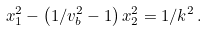Convert formula to latex. <formula><loc_0><loc_0><loc_500><loc_500>x _ { 1 } ^ { 2 } - \left ( { 1 / v _ { b } ^ { 2 } - 1 } \right ) x _ { 2 } ^ { 2 } = 1 / k ^ { 2 } \, .</formula> 